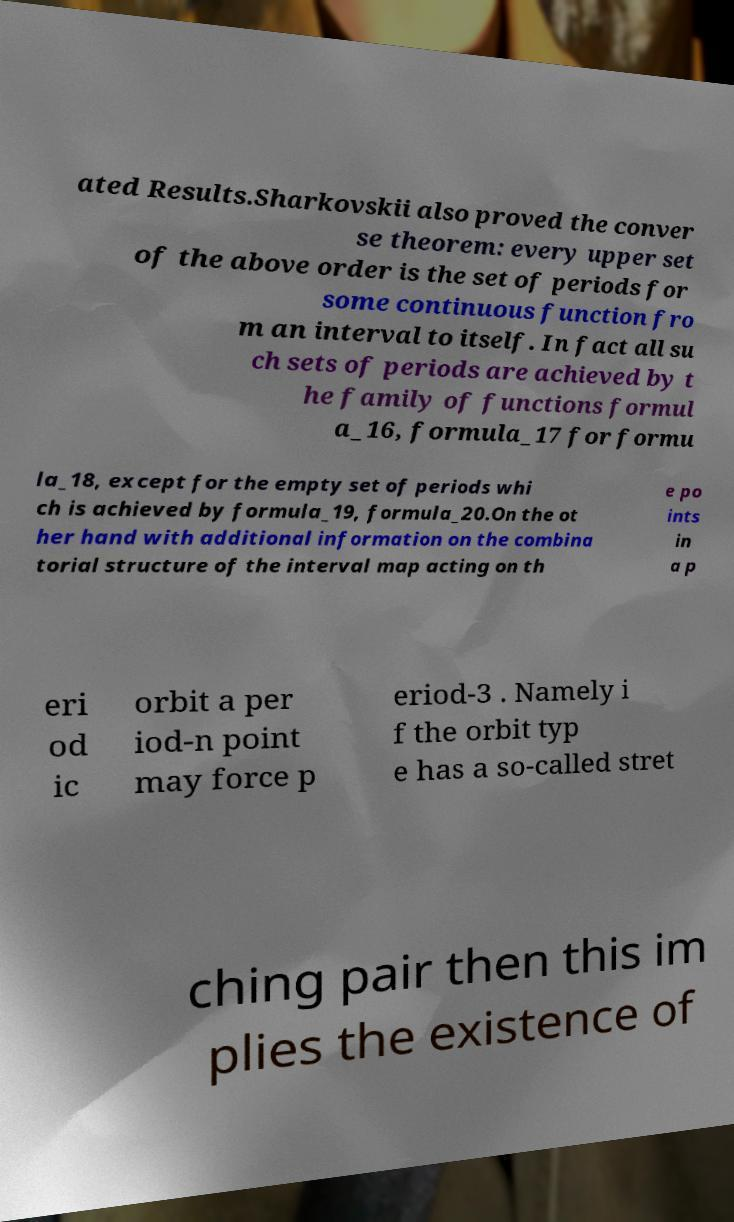What messages or text are displayed in this image? I need them in a readable, typed format. ated Results.Sharkovskii also proved the conver se theorem: every upper set of the above order is the set of periods for some continuous function fro m an interval to itself. In fact all su ch sets of periods are achieved by t he family of functions formul a_16, formula_17 for formu la_18, except for the empty set of periods whi ch is achieved by formula_19, formula_20.On the ot her hand with additional information on the combina torial structure of the interval map acting on th e po ints in a p eri od ic orbit a per iod-n point may force p eriod-3 . Namely i f the orbit typ e has a so-called stret ching pair then this im plies the existence of 